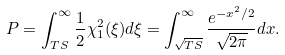<formula> <loc_0><loc_0><loc_500><loc_500>P = \int _ { T S } ^ { \infty } \frac { 1 } { 2 } \chi _ { 1 } ^ { 2 } ( \xi ) d \xi = \int _ { \sqrt { T S } } ^ { \infty } \frac { e ^ { - x ^ { 2 } / 2 } } { \sqrt { 2 \pi } } d x .</formula> 